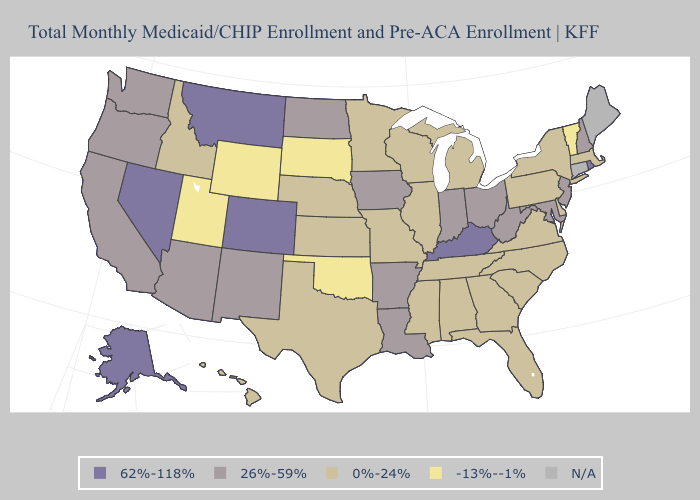What is the value of Arizona?
Concise answer only. 26%-59%. Name the states that have a value in the range 0%-24%?
Concise answer only. Alabama, Delaware, Florida, Georgia, Hawaii, Idaho, Illinois, Kansas, Massachusetts, Michigan, Minnesota, Mississippi, Missouri, Nebraska, New York, North Carolina, Pennsylvania, South Carolina, Tennessee, Texas, Virginia, Wisconsin. Which states hav the highest value in the Northeast?
Write a very short answer. Rhode Island. Name the states that have a value in the range 0%-24%?
Quick response, please. Alabama, Delaware, Florida, Georgia, Hawaii, Idaho, Illinois, Kansas, Massachusetts, Michigan, Minnesota, Mississippi, Missouri, Nebraska, New York, North Carolina, Pennsylvania, South Carolina, Tennessee, Texas, Virginia, Wisconsin. Among the states that border Tennessee , does Missouri have the lowest value?
Concise answer only. Yes. Does Arkansas have the highest value in the South?
Give a very brief answer. No. What is the highest value in states that border North Dakota?
Answer briefly. 62%-118%. Name the states that have a value in the range 26%-59%?
Give a very brief answer. Arizona, Arkansas, California, Indiana, Iowa, Louisiana, Maryland, New Hampshire, New Jersey, New Mexico, North Dakota, Ohio, Oregon, Washington, West Virginia. What is the value of Michigan?
Write a very short answer. 0%-24%. Name the states that have a value in the range N/A?
Be succinct. Connecticut, Maine. Does Nevada have the highest value in the USA?
Give a very brief answer. Yes. Name the states that have a value in the range 0%-24%?
Short answer required. Alabama, Delaware, Florida, Georgia, Hawaii, Idaho, Illinois, Kansas, Massachusetts, Michigan, Minnesota, Mississippi, Missouri, Nebraska, New York, North Carolina, Pennsylvania, South Carolina, Tennessee, Texas, Virginia, Wisconsin. Does Nevada have the highest value in the USA?
Give a very brief answer. Yes. 